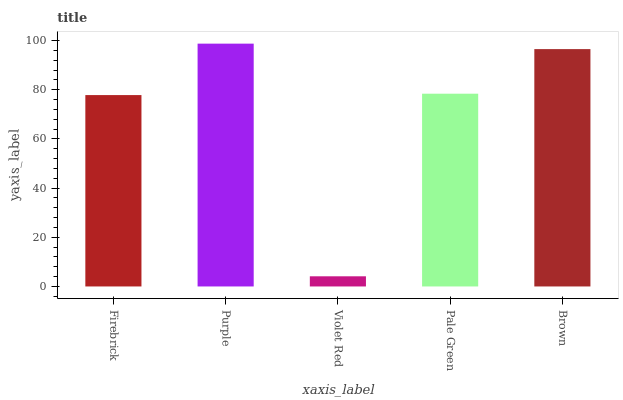Is Violet Red the minimum?
Answer yes or no. Yes. Is Purple the maximum?
Answer yes or no. Yes. Is Purple the minimum?
Answer yes or no. No. Is Violet Red the maximum?
Answer yes or no. No. Is Purple greater than Violet Red?
Answer yes or no. Yes. Is Violet Red less than Purple?
Answer yes or no. Yes. Is Violet Red greater than Purple?
Answer yes or no. No. Is Purple less than Violet Red?
Answer yes or no. No. Is Pale Green the high median?
Answer yes or no. Yes. Is Pale Green the low median?
Answer yes or no. Yes. Is Firebrick the high median?
Answer yes or no. No. Is Firebrick the low median?
Answer yes or no. No. 